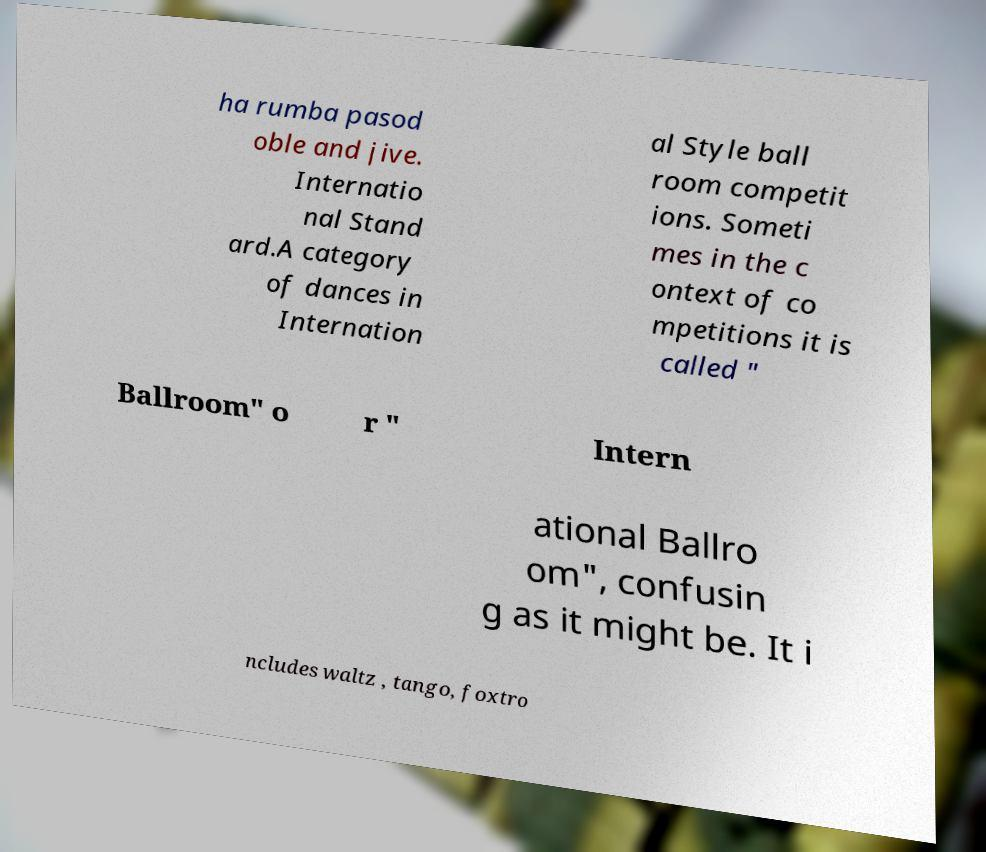Can you accurately transcribe the text from the provided image for me? ha rumba pasod oble and jive. Internatio nal Stand ard.A category of dances in Internation al Style ball room competit ions. Someti mes in the c ontext of co mpetitions it is called " Ballroom" o r " Intern ational Ballro om", confusin g as it might be. It i ncludes waltz , tango, foxtro 